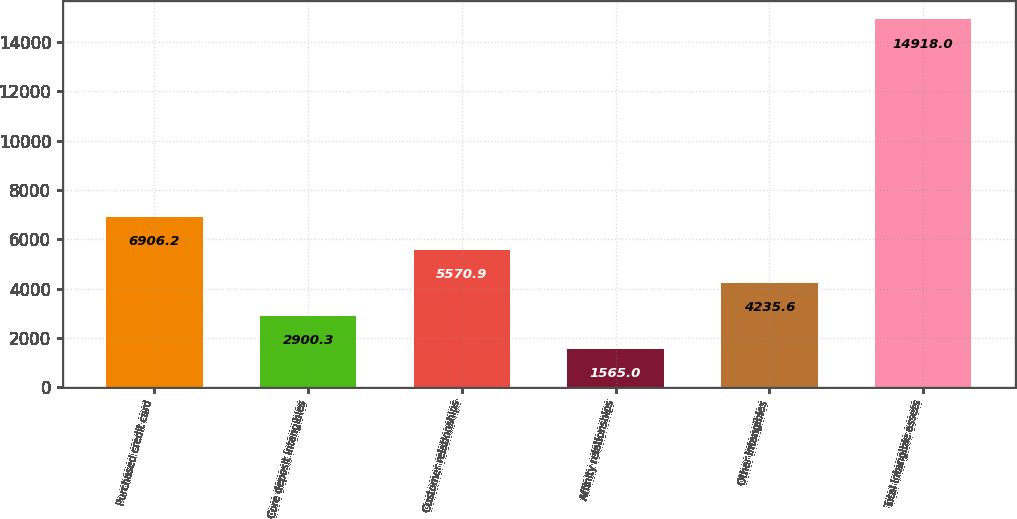<chart> <loc_0><loc_0><loc_500><loc_500><bar_chart><fcel>Purchased credit card<fcel>Core deposit intangibles<fcel>Customer relationships<fcel>Affinity relationships<fcel>Other intangibles<fcel>Total intangible assets<nl><fcel>6906.2<fcel>2900.3<fcel>5570.9<fcel>1565<fcel>4235.6<fcel>14918<nl></chart> 